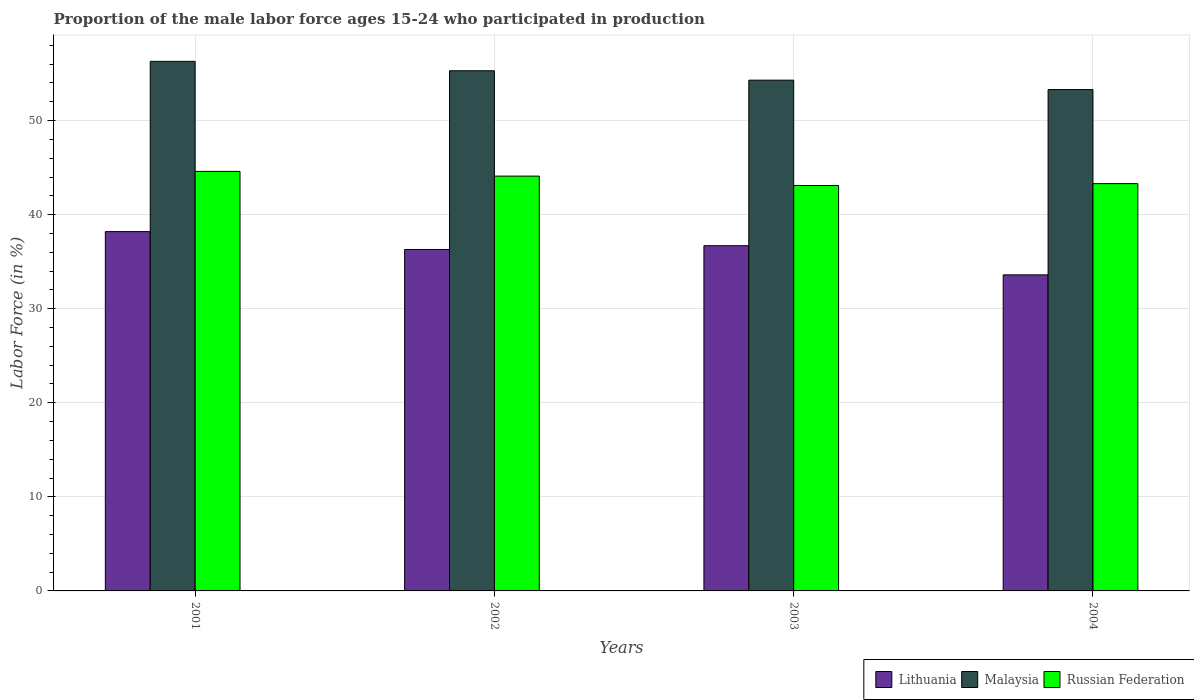How many different coloured bars are there?
Offer a very short reply. 3. Are the number of bars on each tick of the X-axis equal?
Keep it short and to the point. Yes. How many bars are there on the 3rd tick from the right?
Make the answer very short. 3. What is the label of the 3rd group of bars from the left?
Keep it short and to the point. 2003. What is the proportion of the male labor force who participated in production in Lithuania in 2001?
Your answer should be compact. 38.2. Across all years, what is the maximum proportion of the male labor force who participated in production in Lithuania?
Your answer should be compact. 38.2. Across all years, what is the minimum proportion of the male labor force who participated in production in Malaysia?
Your answer should be compact. 53.3. In which year was the proportion of the male labor force who participated in production in Malaysia maximum?
Keep it short and to the point. 2001. What is the total proportion of the male labor force who participated in production in Lithuania in the graph?
Your response must be concise. 144.8. What is the difference between the proportion of the male labor force who participated in production in Lithuania in 2002 and that in 2003?
Keep it short and to the point. -0.4. What is the difference between the proportion of the male labor force who participated in production in Lithuania in 2001 and the proportion of the male labor force who participated in production in Malaysia in 2004?
Your answer should be very brief. -15.1. What is the average proportion of the male labor force who participated in production in Russian Federation per year?
Your answer should be very brief. 43.77. In the year 2001, what is the difference between the proportion of the male labor force who participated in production in Russian Federation and proportion of the male labor force who participated in production in Lithuania?
Give a very brief answer. 6.4. In how many years, is the proportion of the male labor force who participated in production in Malaysia greater than 44 %?
Offer a terse response. 4. What is the ratio of the proportion of the male labor force who participated in production in Russian Federation in 2001 to that in 2002?
Offer a very short reply. 1.01. Is the proportion of the male labor force who participated in production in Lithuania in 2002 less than that in 2003?
Offer a very short reply. Yes. Is the difference between the proportion of the male labor force who participated in production in Russian Federation in 2002 and 2003 greater than the difference between the proportion of the male labor force who participated in production in Lithuania in 2002 and 2003?
Make the answer very short. Yes. What is the difference between the highest and the lowest proportion of the male labor force who participated in production in Lithuania?
Offer a very short reply. 4.6. What does the 3rd bar from the left in 2002 represents?
Your answer should be compact. Russian Federation. What does the 3rd bar from the right in 2003 represents?
Ensure brevity in your answer.  Lithuania. Are all the bars in the graph horizontal?
Keep it short and to the point. No. How many years are there in the graph?
Ensure brevity in your answer.  4. Does the graph contain grids?
Give a very brief answer. Yes. What is the title of the graph?
Provide a succinct answer. Proportion of the male labor force ages 15-24 who participated in production. What is the label or title of the X-axis?
Your answer should be very brief. Years. What is the label or title of the Y-axis?
Make the answer very short. Labor Force (in %). What is the Labor Force (in %) of Lithuania in 2001?
Your answer should be compact. 38.2. What is the Labor Force (in %) of Malaysia in 2001?
Make the answer very short. 56.3. What is the Labor Force (in %) in Russian Federation in 2001?
Ensure brevity in your answer.  44.6. What is the Labor Force (in %) of Lithuania in 2002?
Your response must be concise. 36.3. What is the Labor Force (in %) of Malaysia in 2002?
Offer a very short reply. 55.3. What is the Labor Force (in %) in Russian Federation in 2002?
Your response must be concise. 44.1. What is the Labor Force (in %) in Lithuania in 2003?
Provide a short and direct response. 36.7. What is the Labor Force (in %) of Malaysia in 2003?
Your answer should be compact. 54.3. What is the Labor Force (in %) of Russian Federation in 2003?
Your response must be concise. 43.1. What is the Labor Force (in %) of Lithuania in 2004?
Give a very brief answer. 33.6. What is the Labor Force (in %) of Malaysia in 2004?
Your response must be concise. 53.3. What is the Labor Force (in %) of Russian Federation in 2004?
Your answer should be very brief. 43.3. Across all years, what is the maximum Labor Force (in %) of Lithuania?
Your answer should be compact. 38.2. Across all years, what is the maximum Labor Force (in %) in Malaysia?
Ensure brevity in your answer.  56.3. Across all years, what is the maximum Labor Force (in %) of Russian Federation?
Offer a terse response. 44.6. Across all years, what is the minimum Labor Force (in %) in Lithuania?
Provide a short and direct response. 33.6. Across all years, what is the minimum Labor Force (in %) of Malaysia?
Ensure brevity in your answer.  53.3. Across all years, what is the minimum Labor Force (in %) in Russian Federation?
Keep it short and to the point. 43.1. What is the total Labor Force (in %) of Lithuania in the graph?
Your answer should be compact. 144.8. What is the total Labor Force (in %) of Malaysia in the graph?
Provide a succinct answer. 219.2. What is the total Labor Force (in %) of Russian Federation in the graph?
Provide a short and direct response. 175.1. What is the difference between the Labor Force (in %) of Lithuania in 2001 and that in 2002?
Provide a short and direct response. 1.9. What is the difference between the Labor Force (in %) in Malaysia in 2001 and that in 2003?
Offer a very short reply. 2. What is the difference between the Labor Force (in %) in Malaysia in 2001 and that in 2004?
Provide a short and direct response. 3. What is the difference between the Labor Force (in %) in Russian Federation in 2001 and that in 2004?
Ensure brevity in your answer.  1.3. What is the difference between the Labor Force (in %) of Lithuania in 2002 and that in 2004?
Your answer should be compact. 2.7. What is the difference between the Labor Force (in %) of Malaysia in 2002 and that in 2004?
Provide a short and direct response. 2. What is the difference between the Labor Force (in %) in Russian Federation in 2003 and that in 2004?
Your answer should be very brief. -0.2. What is the difference between the Labor Force (in %) in Lithuania in 2001 and the Labor Force (in %) in Malaysia in 2002?
Make the answer very short. -17.1. What is the difference between the Labor Force (in %) in Lithuania in 2001 and the Labor Force (in %) in Russian Federation in 2002?
Your answer should be compact. -5.9. What is the difference between the Labor Force (in %) of Malaysia in 2001 and the Labor Force (in %) of Russian Federation in 2002?
Make the answer very short. 12.2. What is the difference between the Labor Force (in %) in Lithuania in 2001 and the Labor Force (in %) in Malaysia in 2003?
Provide a short and direct response. -16.1. What is the difference between the Labor Force (in %) of Lithuania in 2001 and the Labor Force (in %) of Russian Federation in 2003?
Keep it short and to the point. -4.9. What is the difference between the Labor Force (in %) of Malaysia in 2001 and the Labor Force (in %) of Russian Federation in 2003?
Your answer should be very brief. 13.2. What is the difference between the Labor Force (in %) in Lithuania in 2001 and the Labor Force (in %) in Malaysia in 2004?
Give a very brief answer. -15.1. What is the difference between the Labor Force (in %) in Malaysia in 2001 and the Labor Force (in %) in Russian Federation in 2004?
Your answer should be compact. 13. What is the difference between the Labor Force (in %) in Lithuania in 2002 and the Labor Force (in %) in Malaysia in 2004?
Make the answer very short. -17. What is the difference between the Labor Force (in %) in Lithuania in 2002 and the Labor Force (in %) in Russian Federation in 2004?
Your answer should be very brief. -7. What is the difference between the Labor Force (in %) of Malaysia in 2002 and the Labor Force (in %) of Russian Federation in 2004?
Your answer should be very brief. 12. What is the difference between the Labor Force (in %) in Lithuania in 2003 and the Labor Force (in %) in Malaysia in 2004?
Offer a very short reply. -16.6. What is the difference between the Labor Force (in %) in Lithuania in 2003 and the Labor Force (in %) in Russian Federation in 2004?
Offer a terse response. -6.6. What is the difference between the Labor Force (in %) of Malaysia in 2003 and the Labor Force (in %) of Russian Federation in 2004?
Your response must be concise. 11. What is the average Labor Force (in %) in Lithuania per year?
Your answer should be compact. 36.2. What is the average Labor Force (in %) of Malaysia per year?
Provide a succinct answer. 54.8. What is the average Labor Force (in %) of Russian Federation per year?
Ensure brevity in your answer.  43.77. In the year 2001, what is the difference between the Labor Force (in %) of Lithuania and Labor Force (in %) of Malaysia?
Give a very brief answer. -18.1. In the year 2001, what is the difference between the Labor Force (in %) in Lithuania and Labor Force (in %) in Russian Federation?
Give a very brief answer. -6.4. In the year 2002, what is the difference between the Labor Force (in %) in Malaysia and Labor Force (in %) in Russian Federation?
Offer a very short reply. 11.2. In the year 2003, what is the difference between the Labor Force (in %) in Lithuania and Labor Force (in %) in Malaysia?
Your answer should be very brief. -17.6. In the year 2003, what is the difference between the Labor Force (in %) of Lithuania and Labor Force (in %) of Russian Federation?
Ensure brevity in your answer.  -6.4. In the year 2003, what is the difference between the Labor Force (in %) of Malaysia and Labor Force (in %) of Russian Federation?
Provide a succinct answer. 11.2. In the year 2004, what is the difference between the Labor Force (in %) in Lithuania and Labor Force (in %) in Malaysia?
Your response must be concise. -19.7. In the year 2004, what is the difference between the Labor Force (in %) of Malaysia and Labor Force (in %) of Russian Federation?
Your answer should be very brief. 10. What is the ratio of the Labor Force (in %) of Lithuania in 2001 to that in 2002?
Provide a short and direct response. 1.05. What is the ratio of the Labor Force (in %) of Malaysia in 2001 to that in 2002?
Your answer should be compact. 1.02. What is the ratio of the Labor Force (in %) in Russian Federation in 2001 to that in 2002?
Provide a short and direct response. 1.01. What is the ratio of the Labor Force (in %) in Lithuania in 2001 to that in 2003?
Offer a terse response. 1.04. What is the ratio of the Labor Force (in %) of Malaysia in 2001 to that in 2003?
Make the answer very short. 1.04. What is the ratio of the Labor Force (in %) in Russian Federation in 2001 to that in 2003?
Provide a succinct answer. 1.03. What is the ratio of the Labor Force (in %) in Lithuania in 2001 to that in 2004?
Keep it short and to the point. 1.14. What is the ratio of the Labor Force (in %) in Malaysia in 2001 to that in 2004?
Provide a succinct answer. 1.06. What is the ratio of the Labor Force (in %) in Malaysia in 2002 to that in 2003?
Keep it short and to the point. 1.02. What is the ratio of the Labor Force (in %) of Russian Federation in 2002 to that in 2003?
Provide a succinct answer. 1.02. What is the ratio of the Labor Force (in %) in Lithuania in 2002 to that in 2004?
Provide a succinct answer. 1.08. What is the ratio of the Labor Force (in %) of Malaysia in 2002 to that in 2004?
Keep it short and to the point. 1.04. What is the ratio of the Labor Force (in %) of Russian Federation in 2002 to that in 2004?
Provide a short and direct response. 1.02. What is the ratio of the Labor Force (in %) in Lithuania in 2003 to that in 2004?
Your answer should be compact. 1.09. What is the ratio of the Labor Force (in %) of Malaysia in 2003 to that in 2004?
Keep it short and to the point. 1.02. What is the difference between the highest and the second highest Labor Force (in %) in Lithuania?
Your response must be concise. 1.5. What is the difference between the highest and the second highest Labor Force (in %) of Russian Federation?
Make the answer very short. 0.5. What is the difference between the highest and the lowest Labor Force (in %) of Lithuania?
Your answer should be very brief. 4.6. 